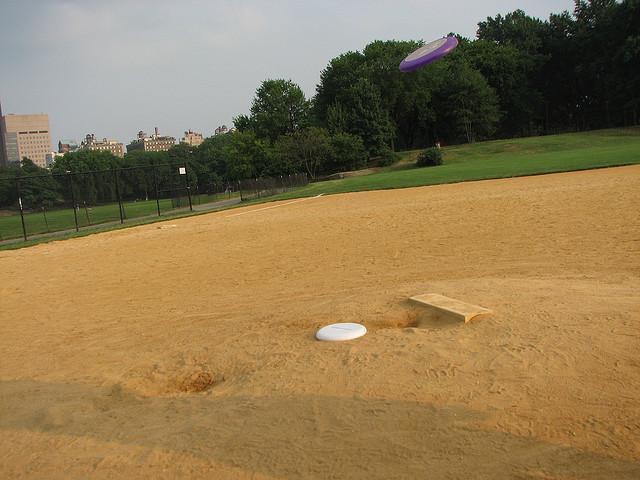How many Frisbees are visible?
Give a very brief answer. 1. How many plants are in the ring around the bench?
Give a very brief answer. 0. 